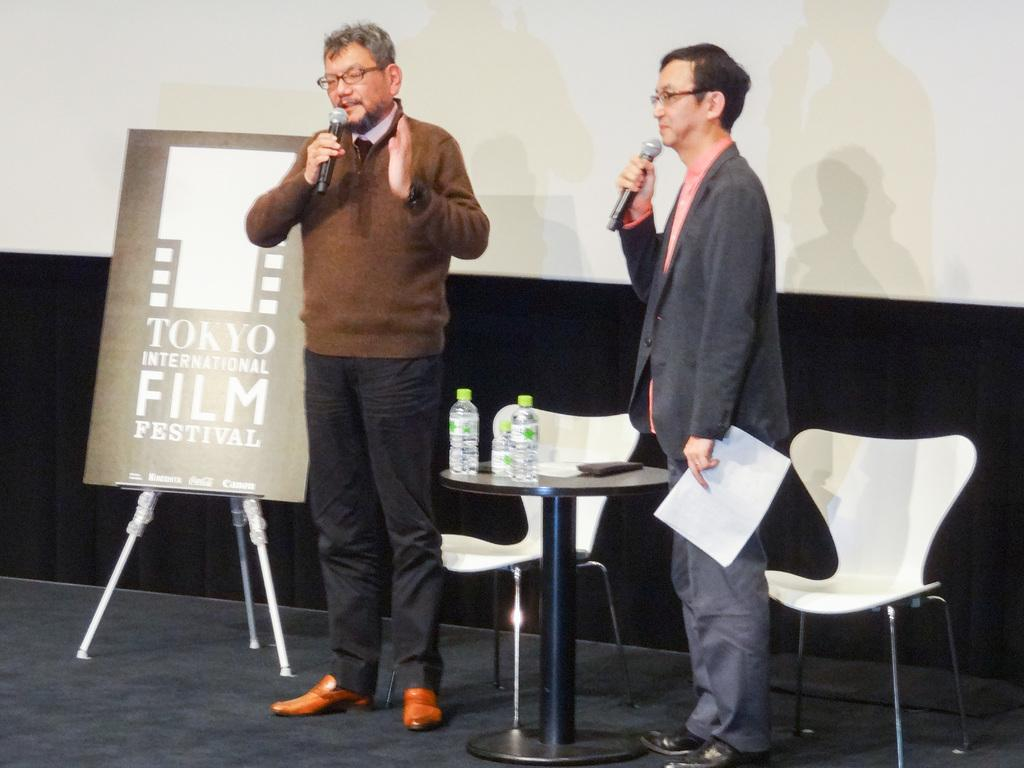How many people are in the image? There are two men in the image. What are the men doing in the image? The men are standing and talking. Can you describe what one of the men is holding? One of the men is holding a microphone. What is on the table in the image? There are water bottles on the table. What type of furniture is present in the image? There are chairs in the image. What type of chin can be seen on the table in the image? There is no chin present on the table in the image. What team are the men representing in the image? There is no indication of a team in the image; it simply shows two men standing and talking. 